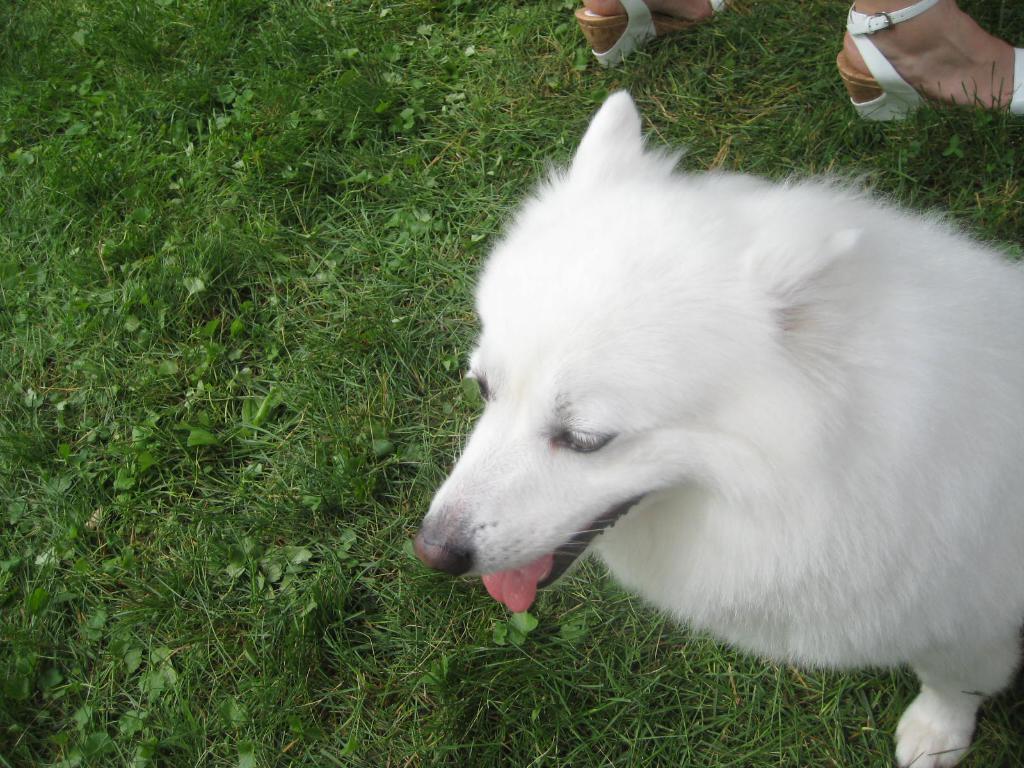Can you describe this image briefly? There is a white color dog, sitting on the grass on the ground, near a person who is standing on the ground. 